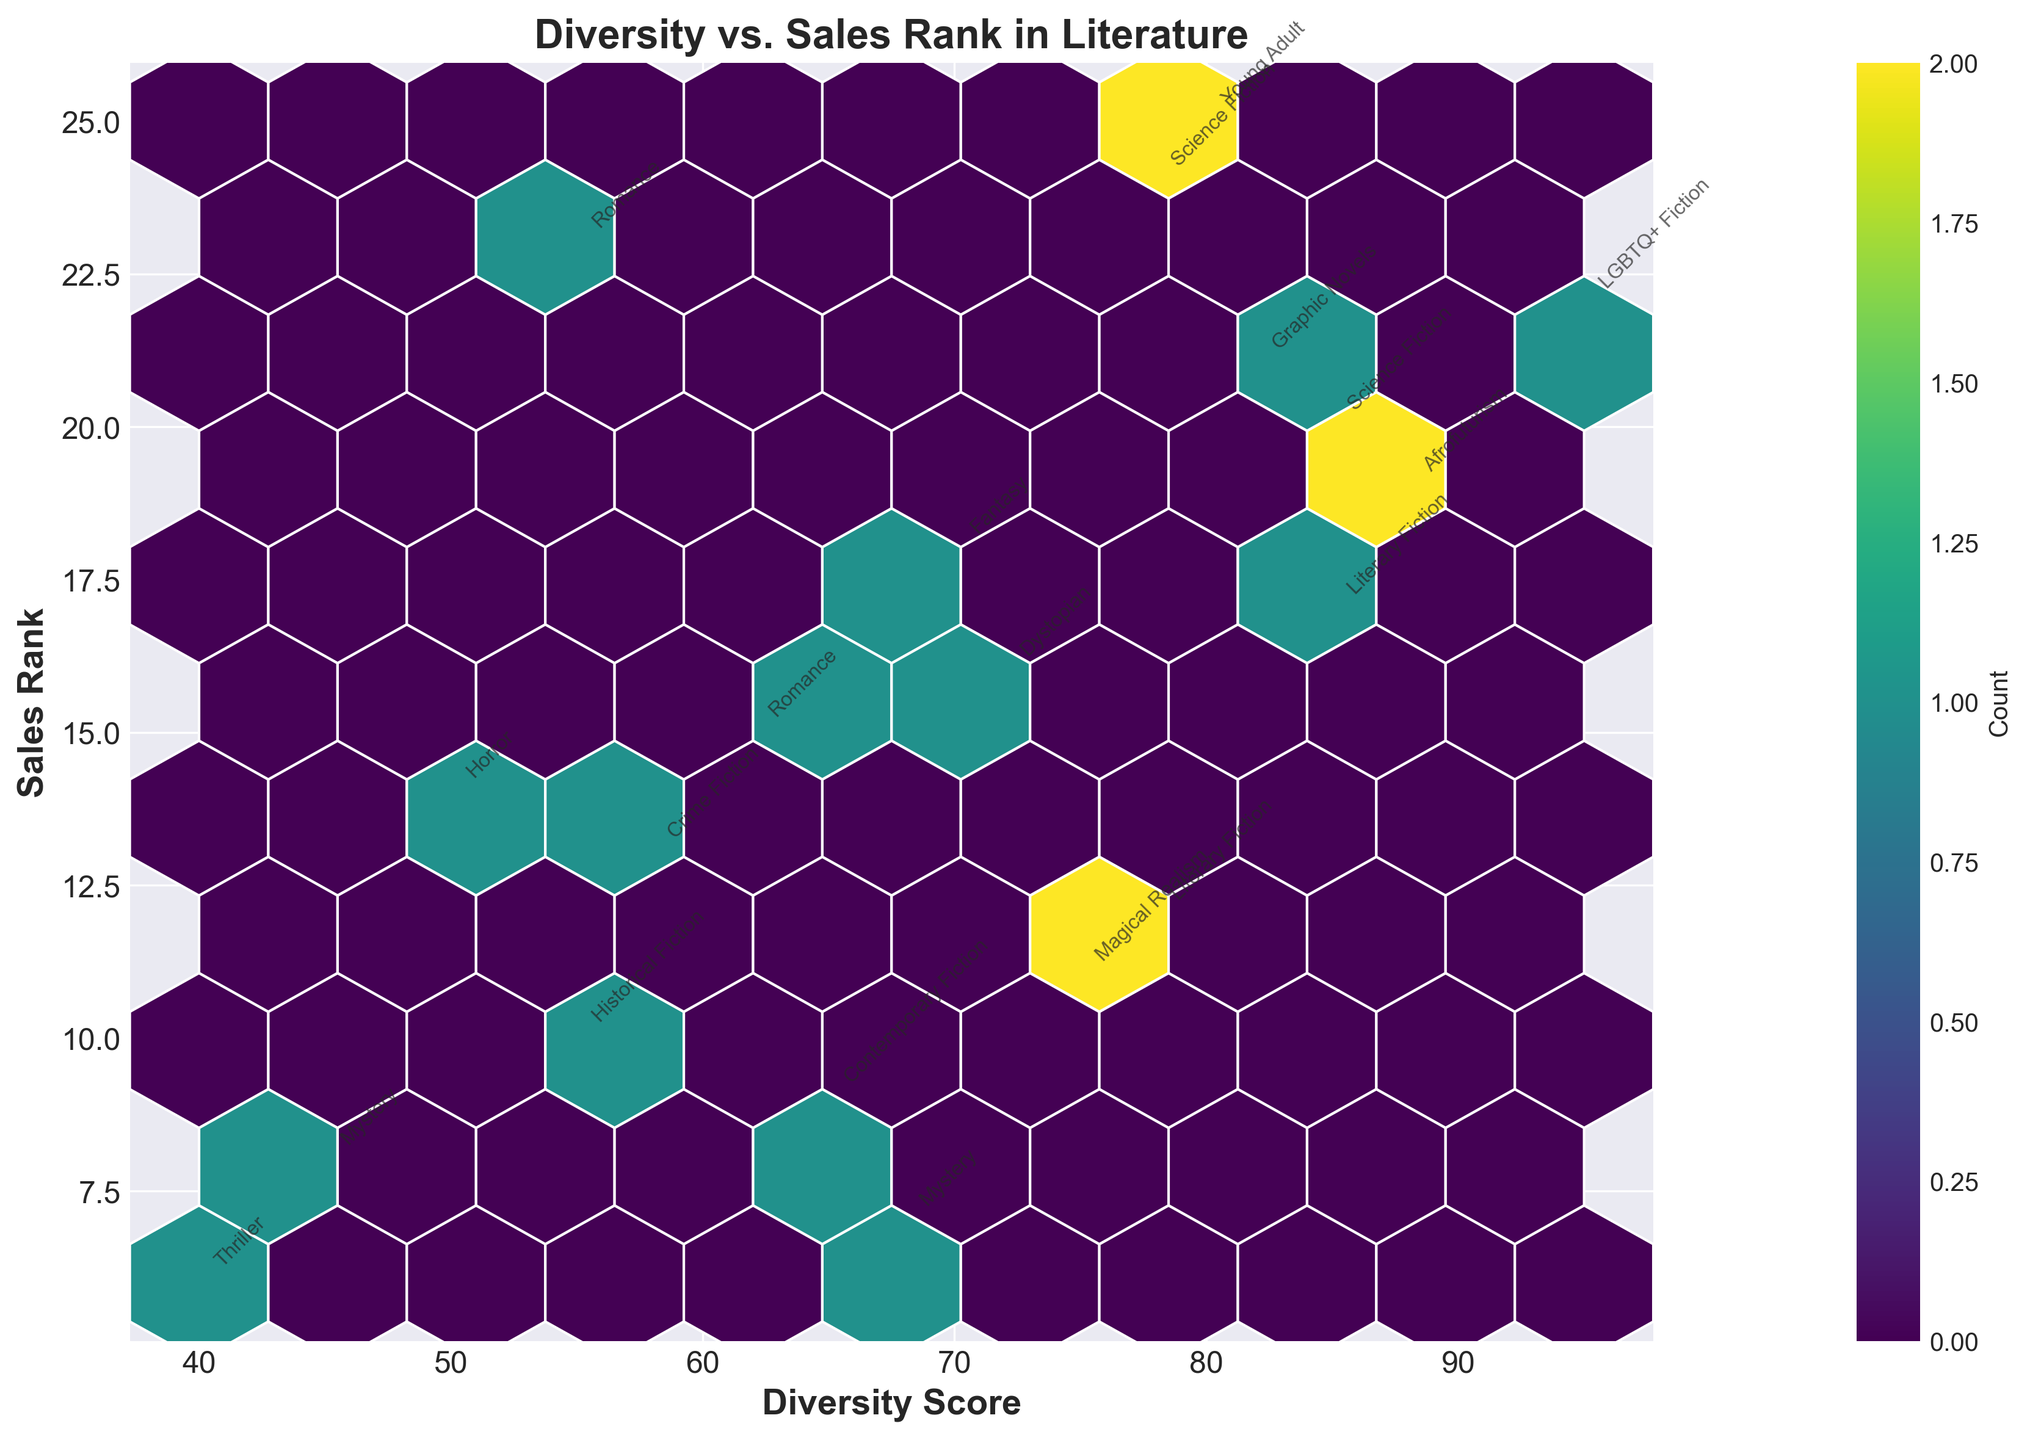What is the title of the plot? The title is usually displayed at the top of the plot in larger and bolder text to provide a quick summary of what the plot represents. In this plot, it’s titled, "Diversity vs. Sales Rank in Literature".
Answer: "Diversity vs. Sales Rank in Literature" What does the color intensity represent on this plot? In the hexbin plot, the color intensity is indicated by the color bar, typically showing the count of data points within each hexagon. Darker colors often represent areas with a higher concentration of points, as shown in the color bar labeled ‘Count’.
Answer: Count of data points Which genre has the highest diversity score annotated on the plot? By examining the annotations in the plot, we look for the data point with the highest diversity score along the x-axis. The genre "LGBTQ+ Fiction" has a diversity score of 95, the highest value.
Answer: LGBTQ+ Fiction How many hexagons have a high concentration of data points? By inspecting the plot, hexagons with darker shades indicate a higher concentration of data points. Counting these darker hexagons on the plot, we can see there are a few regions with higher concentration typically around the middle.
Answer: A few regions Which literary genre falls within both high diversity score and low sales rank on the plot? High diversity score is in the higher range of the x-axis, and low sales rank is in the lower range of the y-axis. From the plot annotations, "Afrofuturism" (88, 19) falls within this range.
Answer: Afrofuturism Is there a visible pattern between diversity score and sales rank in best-selling novels from the plot? To determine the pattern, we observe the distribution and clustering of data points. The plot shows a slight trend where higher diversity scores are somewhat associated with variable sales ranks, but the pattern is not distinctly linear or clear.
Answer: No clear pattern What is the range of the diversity scores displayed on the x-axis? By looking at the x-axis range, it spans from the lowest diversity score annotated to the highest. From the plot, the diversity scores range approximately from 40 to 95 based on data annotations.
Answer: 40 to 95 Which genre has the lowest sales rank? Lower sales rank values are closer to the origin on the y-axis, making them easier to locate. From the annotated points, the genre "Thriller" with a sales rank of 6 is the lowest.
Answer: Thriller Comparing Romance genres published by different publishing houses, which one has a higher diversity score? We compare "Romance" genres annotated on the plot by their diversity scores. Romance published by "Hachette Book Group" has a diversity score of 62, and by "Avon Books" it has a score of 55. So, "Hachette Book Group" has a higher score.
Answer: Hachette Book Group Which genre published by "Penguin Random House" appears in the plot, and what is its diversity score? By examining the annotated points and their publishers, "Literary Fiction" published by "Penguin Random House" is displayed with a diversity score of 78.
Answer: Literary Fiction, 78 